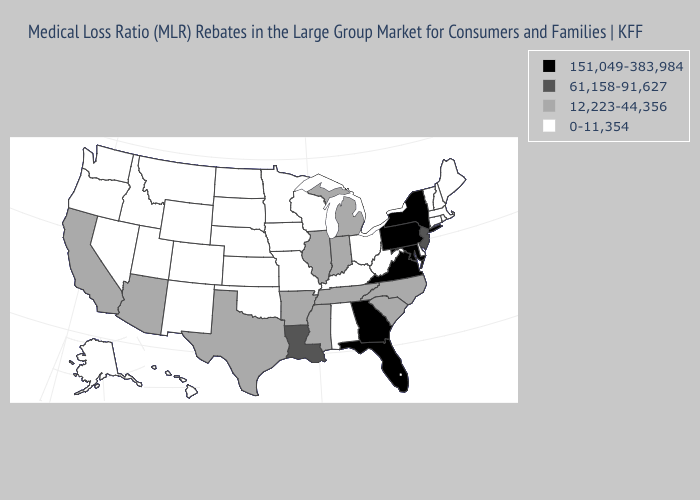Name the states that have a value in the range 0-11,354?
Short answer required. Alabama, Alaska, Colorado, Connecticut, Delaware, Hawaii, Idaho, Iowa, Kansas, Kentucky, Maine, Massachusetts, Minnesota, Missouri, Montana, Nebraska, Nevada, New Hampshire, New Mexico, North Dakota, Ohio, Oklahoma, Oregon, Rhode Island, South Dakota, Utah, Vermont, Washington, West Virginia, Wisconsin, Wyoming. Does Massachusetts have a lower value than North Dakota?
Write a very short answer. No. Does Alabama have the lowest value in the USA?
Write a very short answer. Yes. What is the value of Indiana?
Short answer required. 12,223-44,356. What is the value of Texas?
Write a very short answer. 12,223-44,356. Does the map have missing data?
Answer briefly. No. Does the first symbol in the legend represent the smallest category?
Concise answer only. No. Which states hav the highest value in the West?
Answer briefly. Arizona, California. Does Nevada have the same value as New Hampshire?
Write a very short answer. Yes. Among the states that border West Virginia , does Ohio have the highest value?
Give a very brief answer. No. Does the map have missing data?
Answer briefly. No. Among the states that border Virginia , does North Carolina have the lowest value?
Give a very brief answer. No. Does Wyoming have the highest value in the USA?
Short answer required. No. Among the states that border Mississippi , which have the highest value?
Answer briefly. Louisiana. Does Nebraska have a lower value than Mississippi?
Be succinct. Yes. 